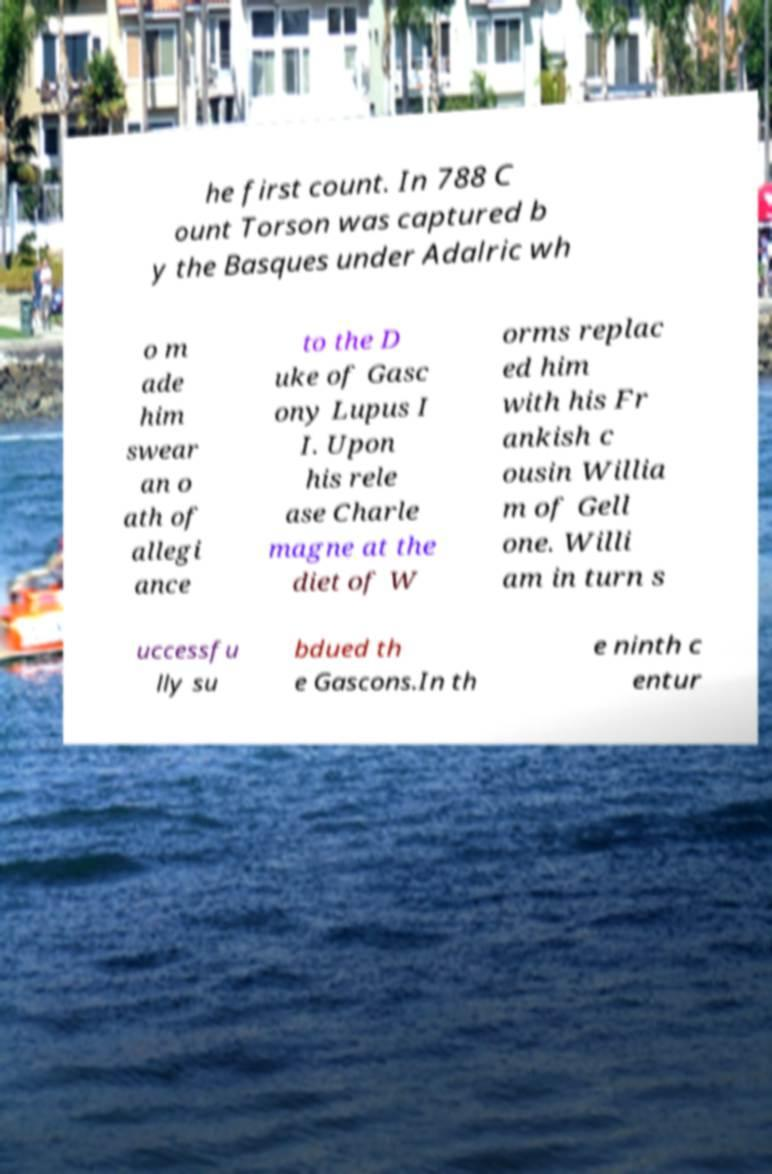Please read and relay the text visible in this image. What does it say? he first count. In 788 C ount Torson was captured b y the Basques under Adalric wh o m ade him swear an o ath of allegi ance to the D uke of Gasc ony Lupus I I. Upon his rele ase Charle magne at the diet of W orms replac ed him with his Fr ankish c ousin Willia m of Gell one. Willi am in turn s uccessfu lly su bdued th e Gascons.In th e ninth c entur 